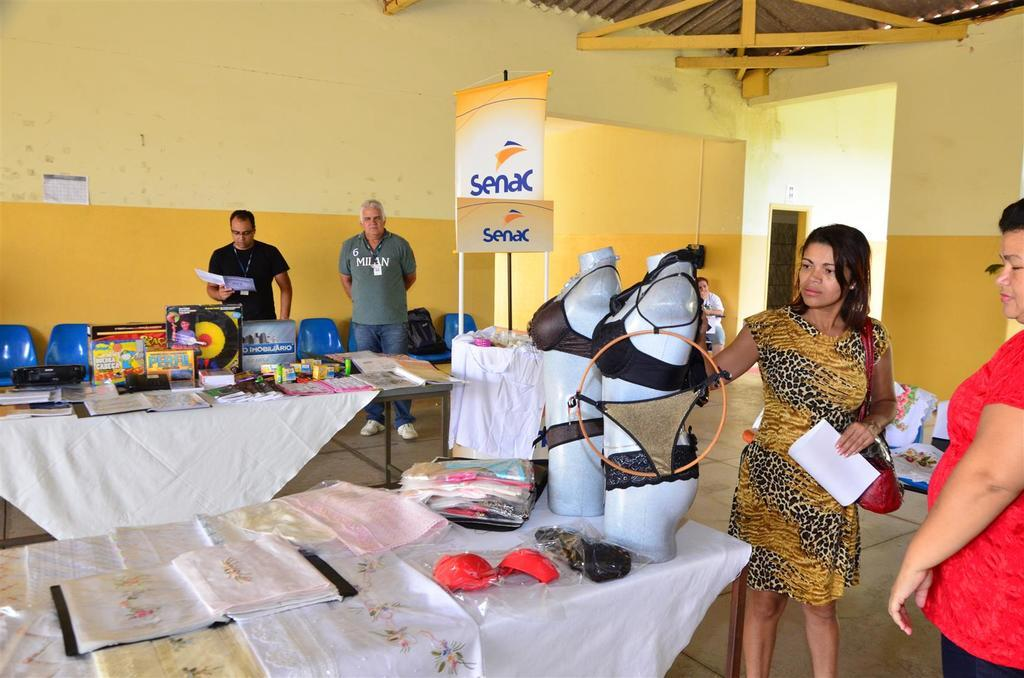What type of space is depicted in the image? There is a room in the image. Who or what can be seen inside the room? There are people in the room. How many tables are present in the room? There are 2 tables in the room. What else can be found in the room besides tables? There are boxes and garments placed on the tables in the room. What type of marble is used for the flooring in the image? There is no mention of marble or flooring in the image; it only describes the presence of a room, people, tables, boxes, and garments. 